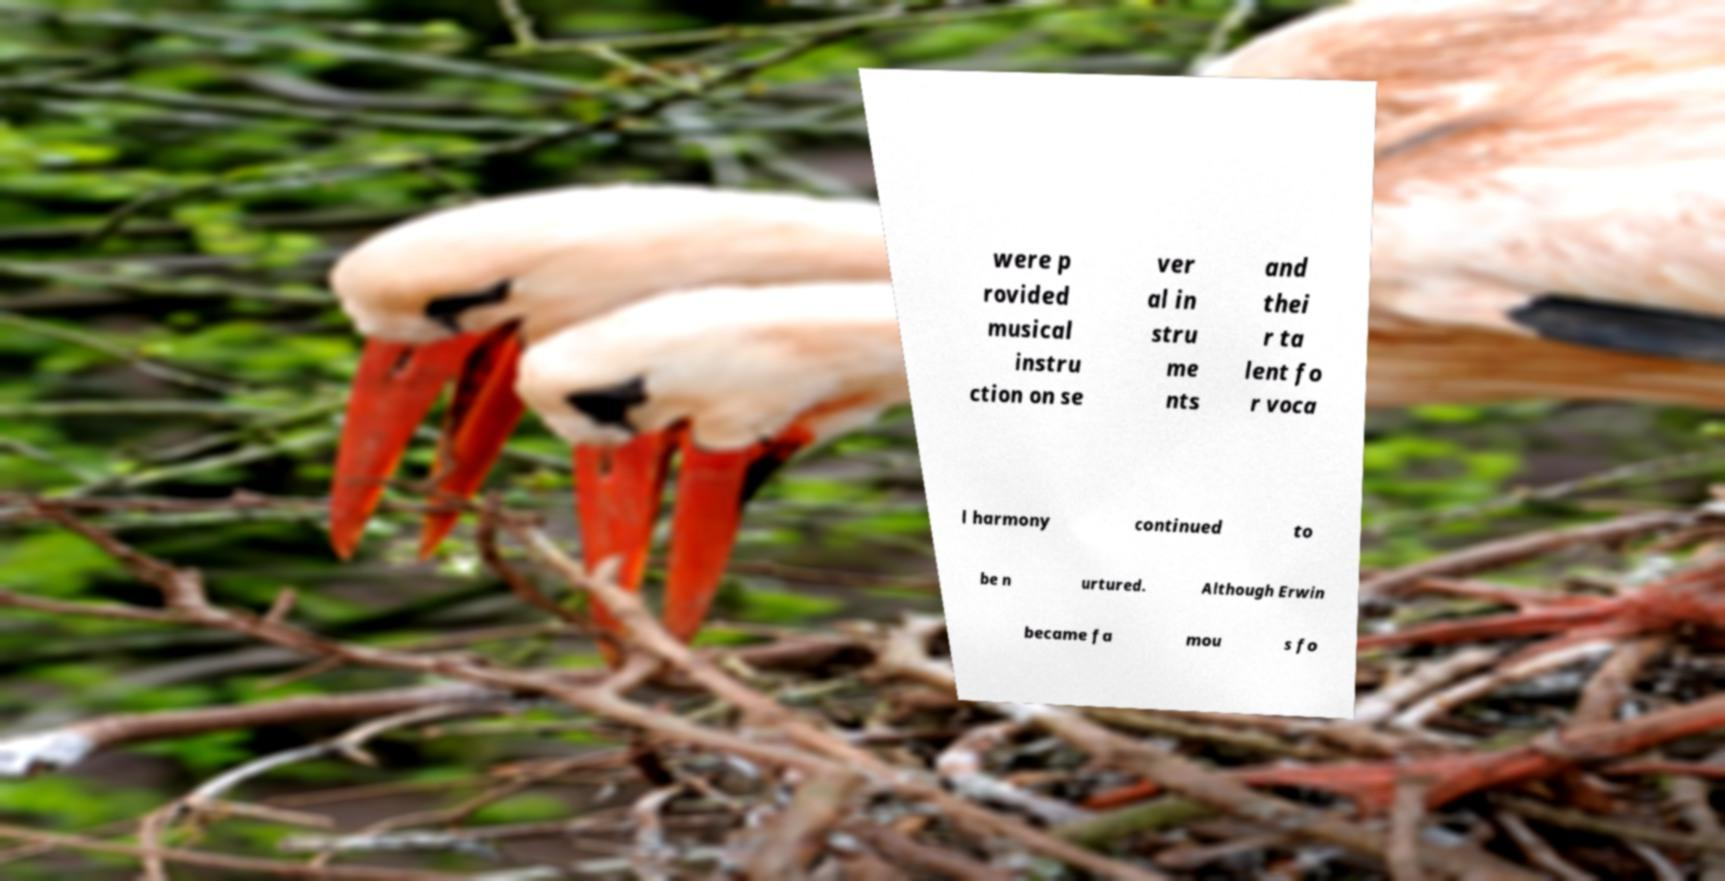For documentation purposes, I need the text within this image transcribed. Could you provide that? were p rovided musical instru ction on se ver al in stru me nts and thei r ta lent fo r voca l harmony continued to be n urtured. Although Erwin became fa mou s fo 